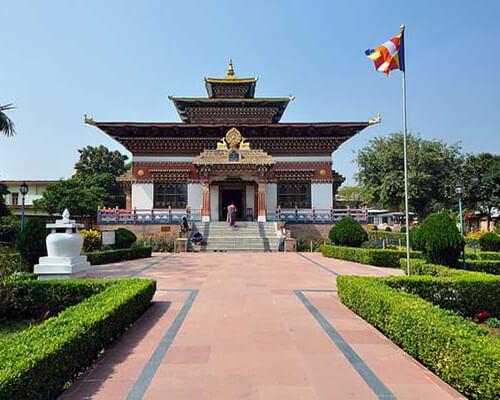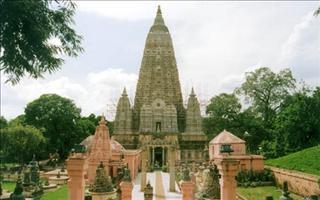The first image is the image on the left, the second image is the image on the right. Examine the images to the left and right. Is the description "At least one flag is waving at the site of one building." accurate? Answer yes or no. Yes. The first image is the image on the left, the second image is the image on the right. Given the left and right images, does the statement "An image shows a tall cone-shaped structure flanked by smaller similarly shaped structures." hold true? Answer yes or no. Yes. 